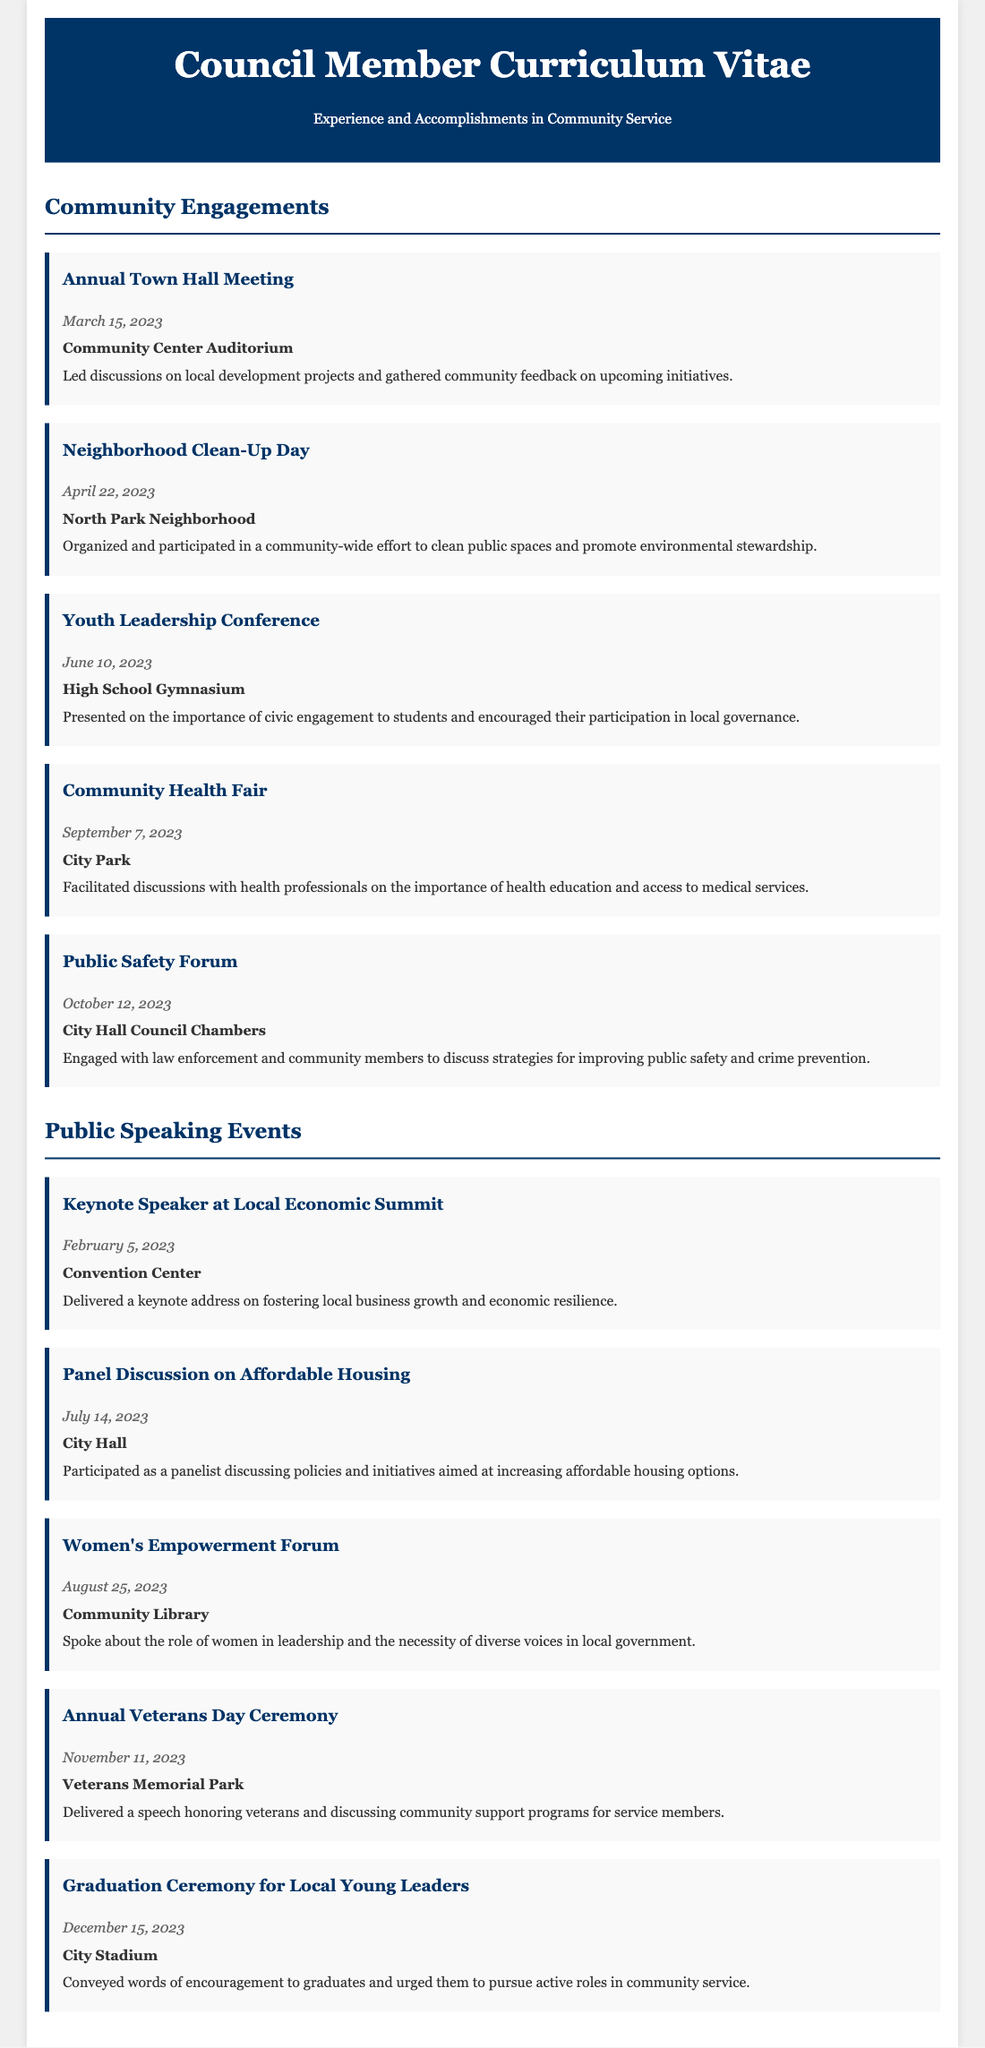What is the date of the Annual Town Hall Meeting? The date of the Annual Town Hall Meeting is mentioned in the document as March 15, 2023.
Answer: March 15, 2023 Where was the Community Health Fair held? The location of the Community Health Fair is stated as City Park in the document.
Answer: City Park Who was the keynote speaker at the Local Economic Summit? The document states that the unnamed council member was the keynote speaker.
Answer: Council Member What topic was discussed at the Youth Leadership Conference? The document indicates that the importance of civic engagement was discussed.
Answer: Civic engagement How many public speaking events are listed in the document? The document lists a total of five public speaking events.
Answer: Five What was the purpose of the Neighborhood Clean-Up Day? The document describes the purpose as promoting environmental stewardship.
Answer: Environmental stewardship On which date is the Annual Veterans Day Ceremony scheduled? The ceremony is scheduled for November 11, 2023, as noted in the document.
Answer: November 11, 2023 What event took place on June 10, 2023? The event on June 10, 2023, is the Youth Leadership Conference, as specified in the document.
Answer: Youth Leadership Conference What role did the council member play at the Women's Empowerment Forum? The document mentions that they spoke about the role of women in leadership.
Answer: Spoke about women's leadership 